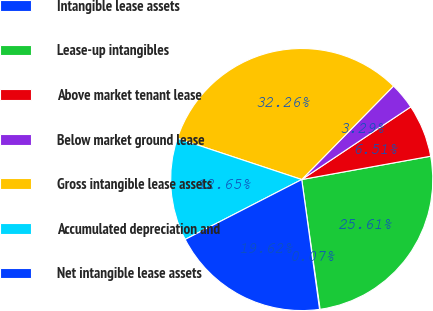Convert chart to OTSL. <chart><loc_0><loc_0><loc_500><loc_500><pie_chart><fcel>Intangible lease assets<fcel>Lease-up intangibles<fcel>Above market tenant lease<fcel>Below market ground lease<fcel>Gross intangible lease assets<fcel>Accumulated depreciation and<fcel>Net intangible lease assets<nl><fcel>0.07%<fcel>25.61%<fcel>6.51%<fcel>3.29%<fcel>32.26%<fcel>12.65%<fcel>19.62%<nl></chart> 